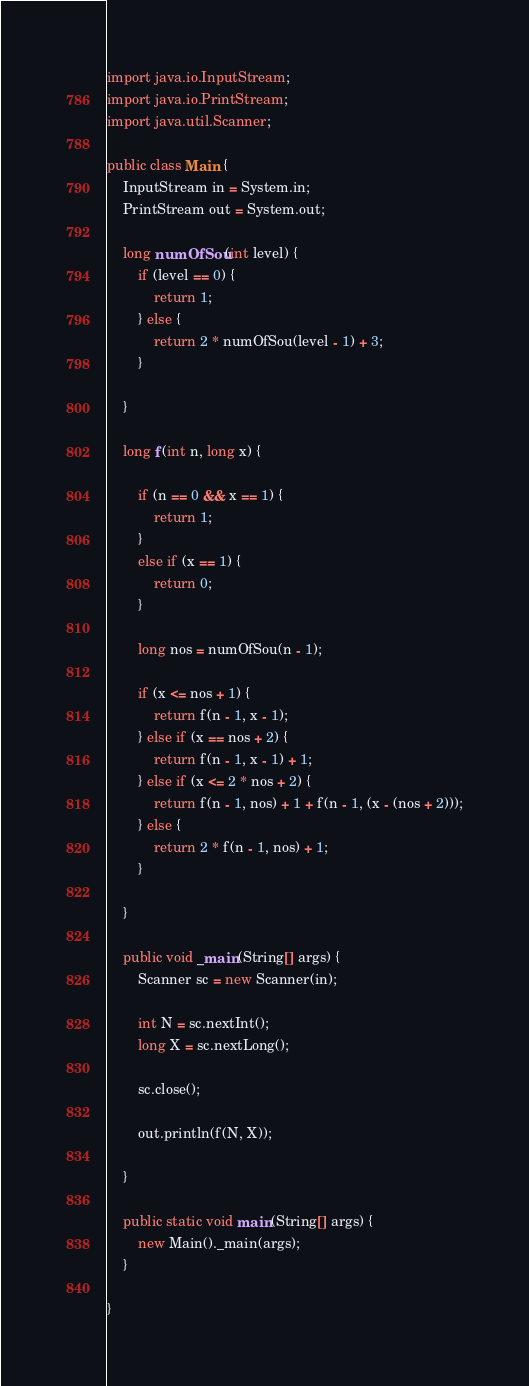<code> <loc_0><loc_0><loc_500><loc_500><_Java_>import java.io.InputStream;
import java.io.PrintStream;
import java.util.Scanner;

public class Main {
	InputStream in = System.in;
	PrintStream out = System.out;

	long numOfSou(int level) {
		if (level == 0) {
			return 1;
		} else {
			return 2 * numOfSou(level - 1) + 3;
		}

	}

	long f(int n, long x) {

		if (n == 0 && x == 1) {
			return 1;
		}
		else if (x == 1) {
			return 0;
		}

		long nos = numOfSou(n - 1);

		if (x <= nos + 1) {
			return f(n - 1, x - 1);
		} else if (x == nos + 2) {
			return f(n - 1, x - 1) + 1;
		} else if (x <= 2 * nos + 2) {
			return f(n - 1, nos) + 1 + f(n - 1, (x - (nos + 2)));
		} else {
			return 2 * f(n - 1, nos) + 1;
		}

	}

	public void _main(String[] args) {
		Scanner sc = new Scanner(in);

		int N = sc.nextInt();
		long X = sc.nextLong();

		sc.close();

		out.println(f(N, X));

	}

	public static void main(String[] args) {
		new Main()._main(args);
	}

}
</code> 